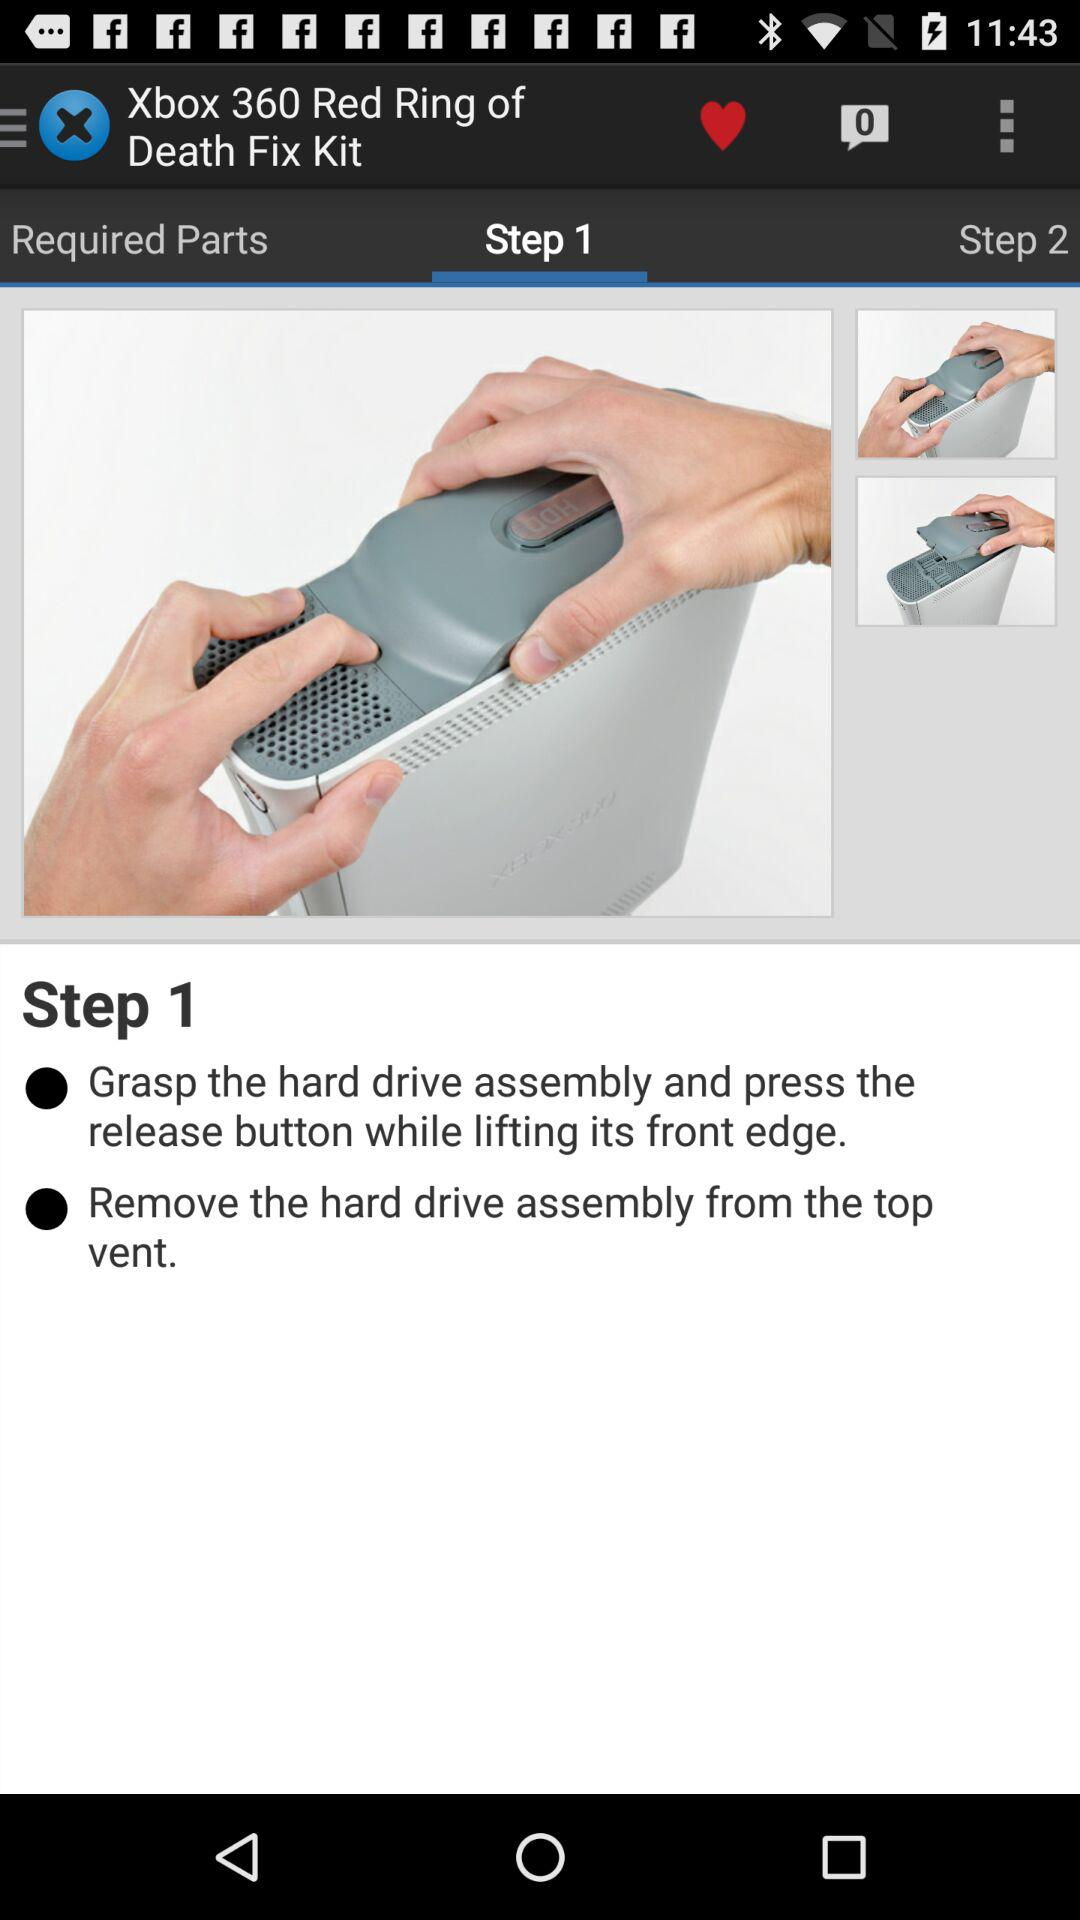How many more steps are there after the first step?
Answer the question using a single word or phrase. 1 